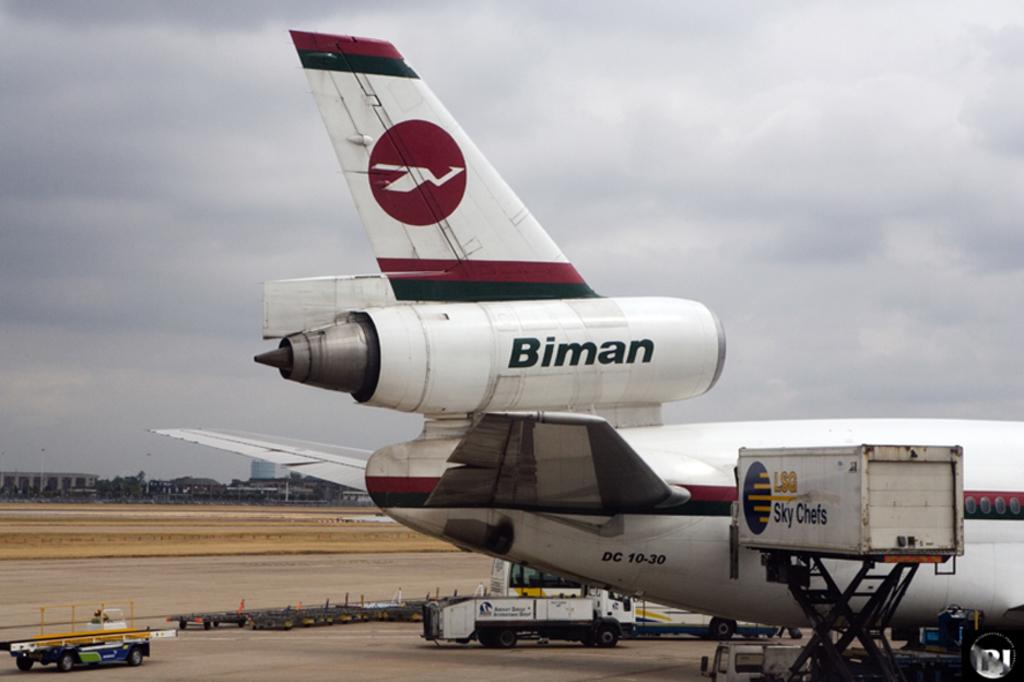<image>
Provide a brief description of the given image. A maroon, white and black plane shown with the word Binman on it. 